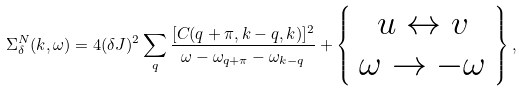Convert formula to latex. <formula><loc_0><loc_0><loc_500><loc_500>\Sigma _ { \delta } ^ { N } ( k , \omega ) = 4 ( \delta J ) ^ { 2 } \sum _ { q } \frac { [ C ( q + \pi , k - q , k ) ] ^ { 2 } } { \omega - \omega _ { q + \pi } - \omega _ { k - q } } + \left \{ \begin{array} { c } u \leftrightarrow v \\ \omega \rightarrow - \omega \end{array} \right \} ,</formula> 